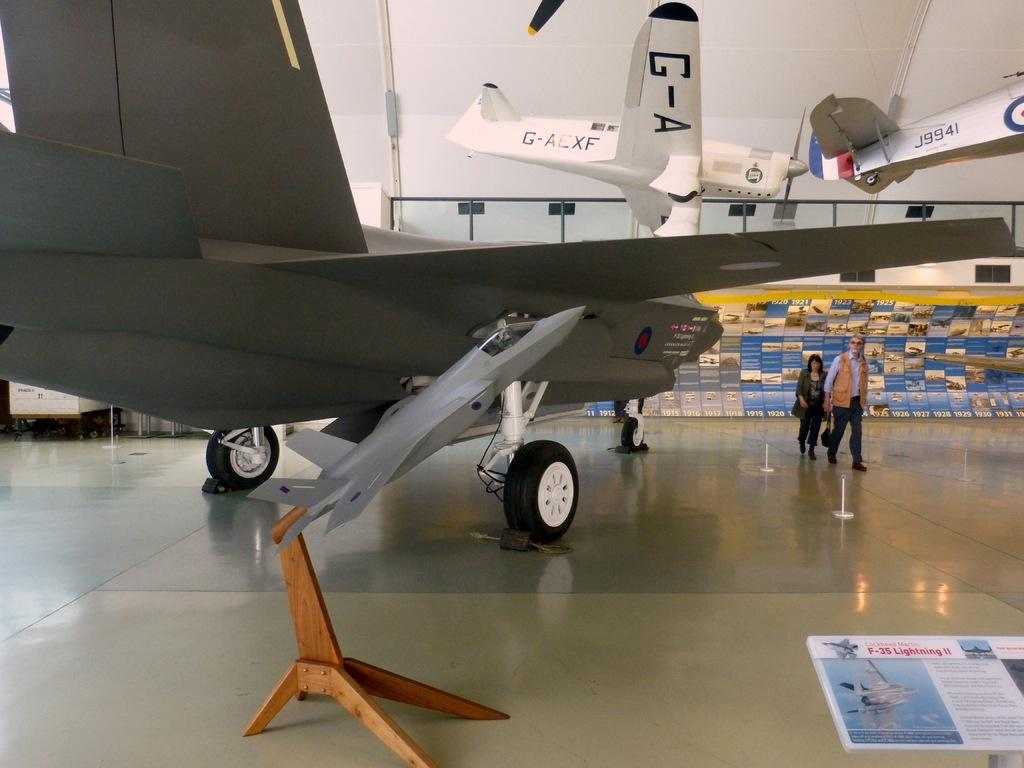<image>
Relay a brief, clear account of the picture shown. planes displayed in a museum like a G-AEXF or J9941 